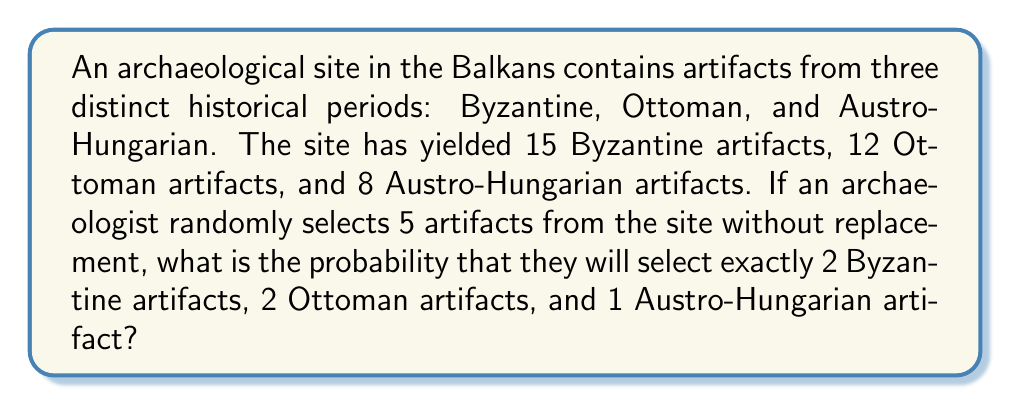Show me your answer to this math problem. To solve this problem, we'll use the concept of combinatorics and the hypergeometric distribution.

1. First, let's calculate the total number of artifacts:
   $15 + 12 + 8 = 35$ total artifacts

2. Now, we need to calculate the number of ways to select:
   - 2 out of 15 Byzantine artifacts
   - 2 out of 12 Ottoman artifacts
   - 1 out of 8 Austro-Hungarian artifacts

3. We can use the combination formula for each:
   Byzantine: $\binom{15}{2}$
   Ottoman: $\binom{12}{2}$
   Austro-Hungarian: $\binom{8}{1}$

4. Calculate each combination:
   $\binom{15}{2} = \frac{15!}{2!(15-2)!} = \frac{15!}{2!13!} = 105$
   $\binom{12}{2} = \frac{12!}{2!(12-2)!} = \frac{12!}{2!10!} = 66$
   $\binom{8}{1} = \frac{8!}{1!(8-1)!} = \frac{8!}{1!7!} = 8$

5. Multiply these results to get the total number of favorable outcomes:
   $105 \times 66 \times 8 = 55,440$

6. Calculate the total number of ways to select 5 artifacts out of 35:
   $\binom{35}{5} = \frac{35!}{5!(35-5)!} = \frac{35!}{5!30!} = 324,632$

7. The probability is the number of favorable outcomes divided by the total number of possible outcomes:

   $$P(\text{2 Byzantine, 2 Ottoman, 1 Austro-Hungarian}) = \frac{55,440}{324,632}$$

8. Simplify the fraction:
   $$\frac{55,440}{324,632} = \frac{8,520}{49,943} \approx 0.1706$$

Therefore, the probability is $\frac{8,520}{49,943}$ or approximately 0.1706 or 17.06%.
Answer: $\frac{8,520}{49,943}$ or approximately 0.1706 (17.06%) 